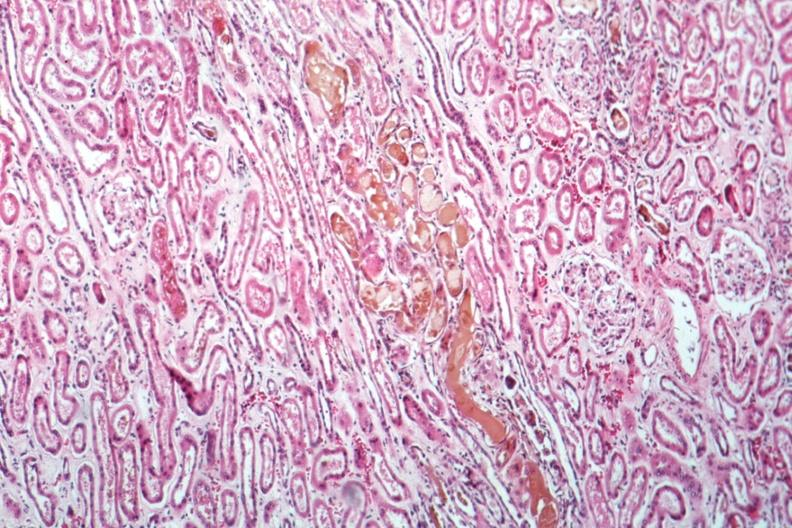s kidney present?
Answer the question using a single word or phrase. Yes 